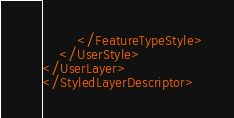Convert code to text. <code><loc_0><loc_0><loc_500><loc_500><_Scheme_>		</FeatureTypeStyle>
	</UserStyle>
</UserLayer>
</StyledLayerDescriptor></code> 